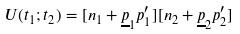Convert formula to latex. <formula><loc_0><loc_0><loc_500><loc_500>U ( t _ { 1 } ; t _ { 2 } ) = [ n _ { 1 } + \underline { p } _ { 1 } p _ { 1 } ^ { \prime } ] [ n _ { 2 } + \underline { p } _ { 2 } p _ { 2 } ^ { \prime } ]</formula> 